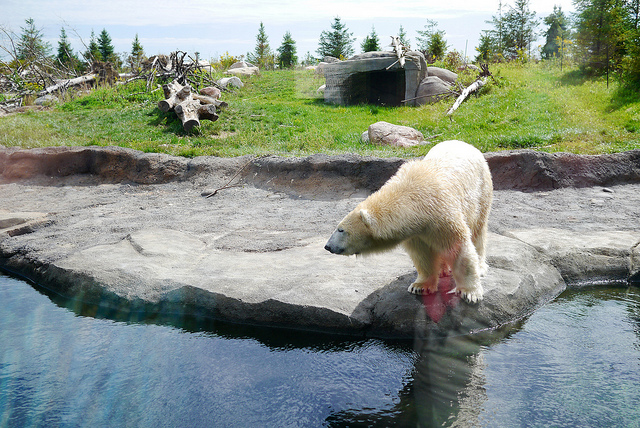What type of animal is shown in this image? The animal in the image is a polar bear.  What is the polar bear doing in the image? The polar bear appears to be standing on a rock at the edge of a water pool, looking down, perhaps searching for something in the water or contemplating entering it. 